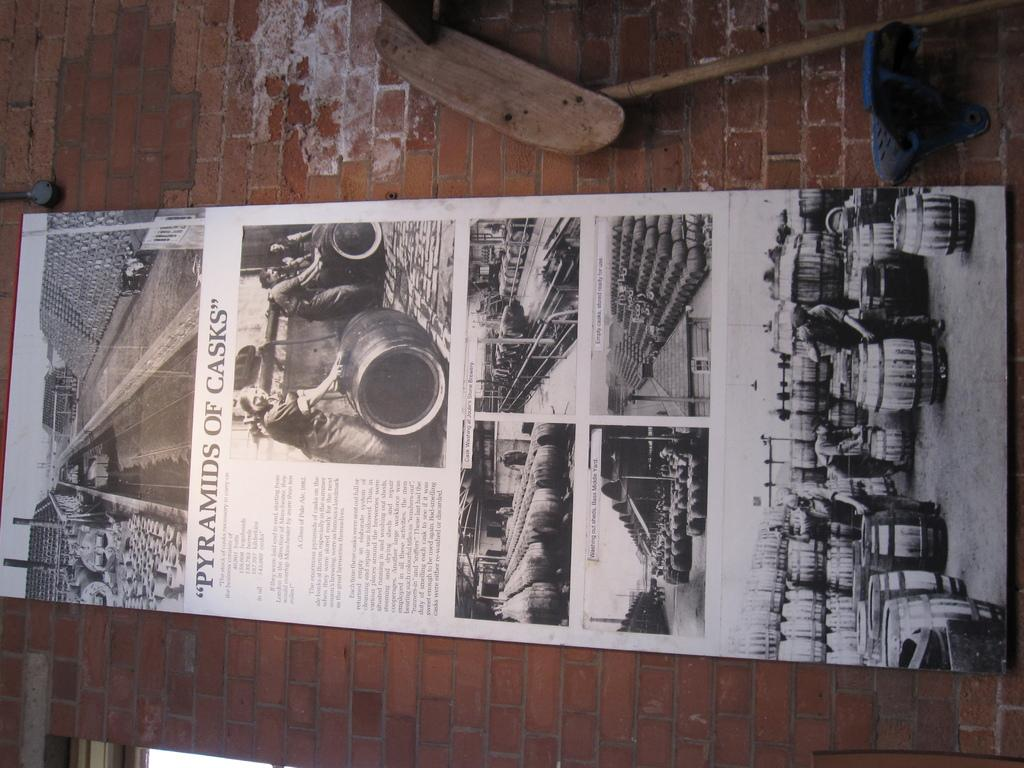What is the main subject of the image? The main subject of the image is a board with paragraphs and photos. Where is the board located in the image? The board is attached to a wall. What can be seen on the right side of the board? There are some items on the right side of the board. How many seats are visible in the image? There are no seats visible in the image; it features a board with paragraphs and photos attached to a wall. What type of boundary is depicted in the image? There is no boundary depicted in the image; it features a board with paragraphs and photos attached to a wall. 